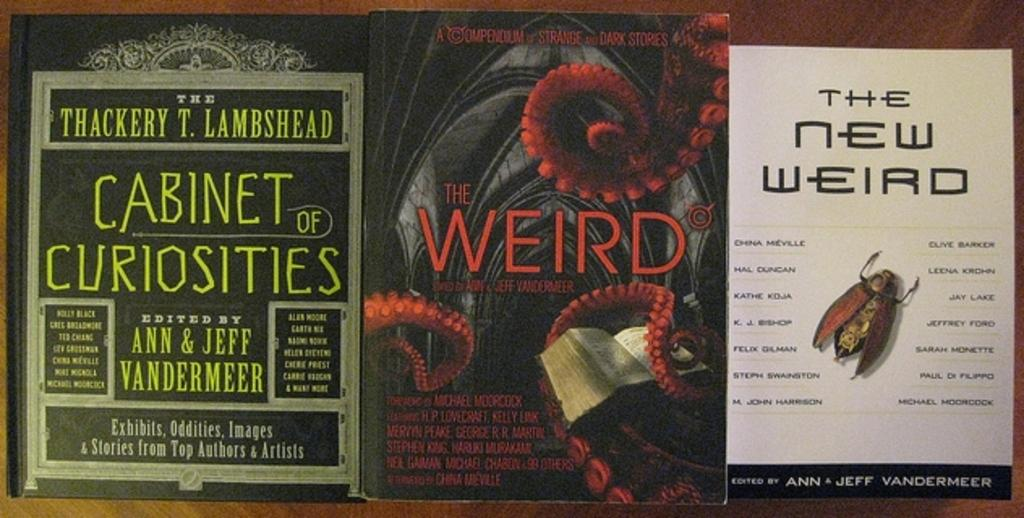<image>
Share a concise interpretation of the image provided. three books; cabinet of monsters, the Weird, and the new weird, are lined up on a table 